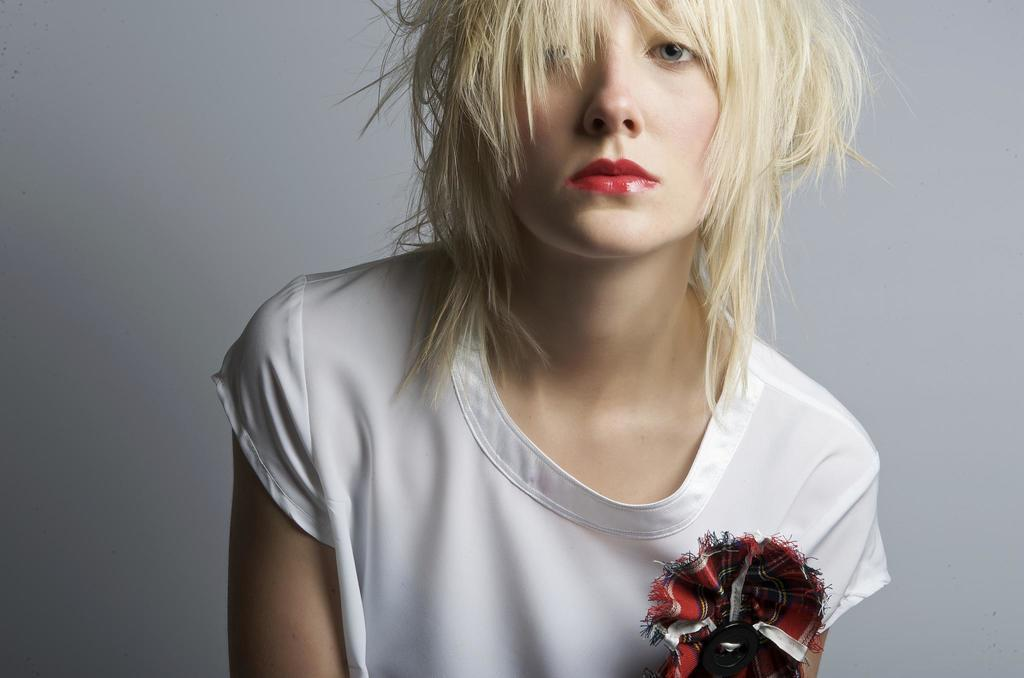Who or what is the main subject in the image? There is a person in the image. Can you describe the position of the person in the image? The person is in front of the image. What can be seen behind the person in the image? There is a wall behind the person. What type of toothpaste is being used by the person in the image? There is no toothpaste present in the image, as it features a person standing in front of a wall. 